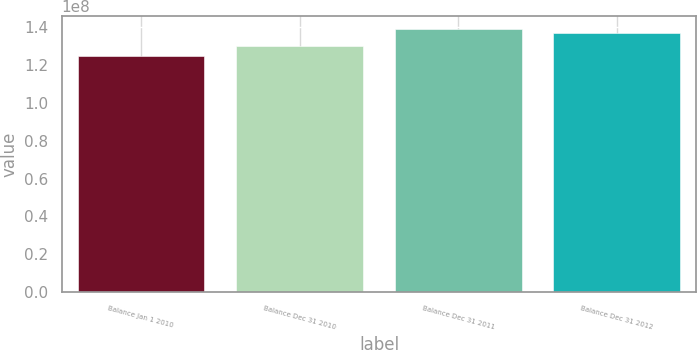Convert chart to OTSL. <chart><loc_0><loc_0><loc_500><loc_500><bar_chart><fcel>Balance Jan 1 2010<fcel>Balance Dec 31 2010<fcel>Balance Dec 31 2011<fcel>Balance Dec 31 2012<nl><fcel>1.24905e+08<fcel>1.30191e+08<fcel>1.38684e+08<fcel>1.37007e+08<nl></chart> 